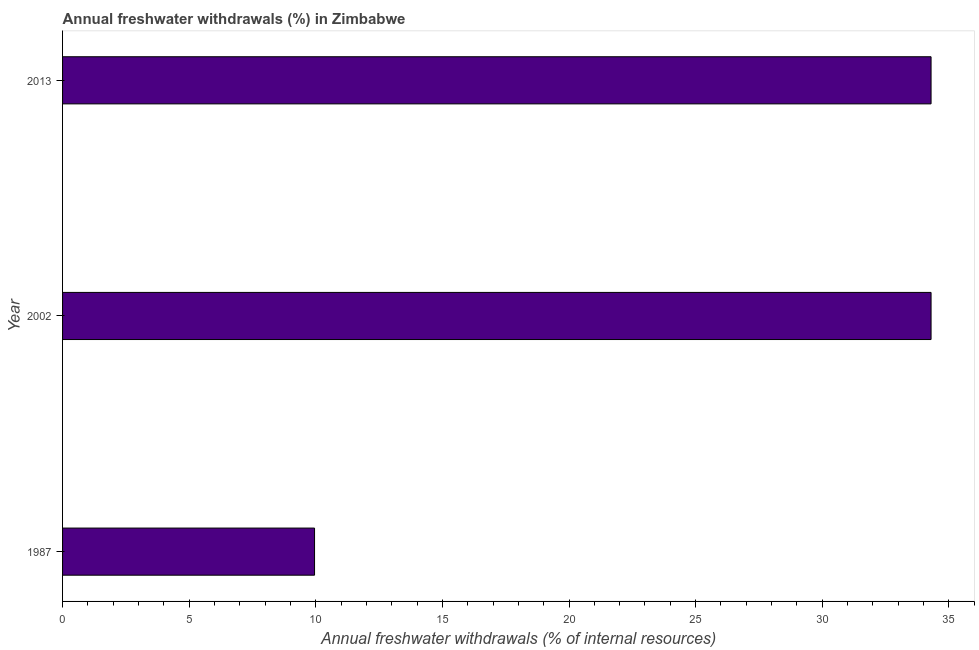Does the graph contain grids?
Make the answer very short. No. What is the title of the graph?
Offer a terse response. Annual freshwater withdrawals (%) in Zimbabwe. What is the label or title of the X-axis?
Give a very brief answer. Annual freshwater withdrawals (% of internal resources). What is the label or title of the Y-axis?
Keep it short and to the point. Year. What is the annual freshwater withdrawals in 2013?
Offer a very short reply. 34.3. Across all years, what is the maximum annual freshwater withdrawals?
Ensure brevity in your answer.  34.3. Across all years, what is the minimum annual freshwater withdrawals?
Provide a succinct answer. 9.95. In which year was the annual freshwater withdrawals maximum?
Offer a terse response. 2002. What is the sum of the annual freshwater withdrawals?
Provide a short and direct response. 78.55. What is the difference between the annual freshwater withdrawals in 2002 and 2013?
Your response must be concise. 0. What is the average annual freshwater withdrawals per year?
Ensure brevity in your answer.  26.18. What is the median annual freshwater withdrawals?
Make the answer very short. 34.3. Is the sum of the annual freshwater withdrawals in 1987 and 2002 greater than the maximum annual freshwater withdrawals across all years?
Ensure brevity in your answer.  Yes. What is the difference between the highest and the lowest annual freshwater withdrawals?
Provide a short and direct response. 24.35. How many bars are there?
Your answer should be compact. 3. What is the difference between two consecutive major ticks on the X-axis?
Your answer should be compact. 5. What is the Annual freshwater withdrawals (% of internal resources) of 1987?
Keep it short and to the point. 9.95. What is the Annual freshwater withdrawals (% of internal resources) of 2002?
Your response must be concise. 34.3. What is the Annual freshwater withdrawals (% of internal resources) of 2013?
Your answer should be compact. 34.3. What is the difference between the Annual freshwater withdrawals (% of internal resources) in 1987 and 2002?
Offer a very short reply. -24.35. What is the difference between the Annual freshwater withdrawals (% of internal resources) in 1987 and 2013?
Your answer should be very brief. -24.35. What is the ratio of the Annual freshwater withdrawals (% of internal resources) in 1987 to that in 2002?
Your response must be concise. 0.29. What is the ratio of the Annual freshwater withdrawals (% of internal resources) in 1987 to that in 2013?
Provide a short and direct response. 0.29. 